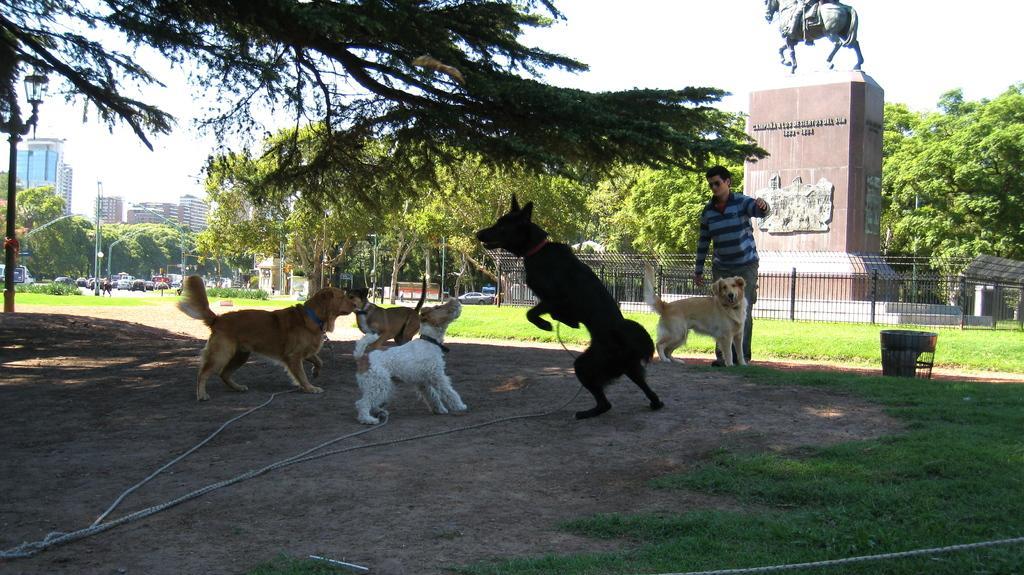Please provide a concise description of this image. In the picture we can see some dogs are playing under the tree on the surface and near to it, we can see some grass surface and a man standing, and behind him we can see a part of grass surface with a stone and sculpture of a person sitting on a horse and around the stone we can see railing and behind it we can see trees and beside it we can see some cars on the road and in the background also we can see some trees, poles and sky. 